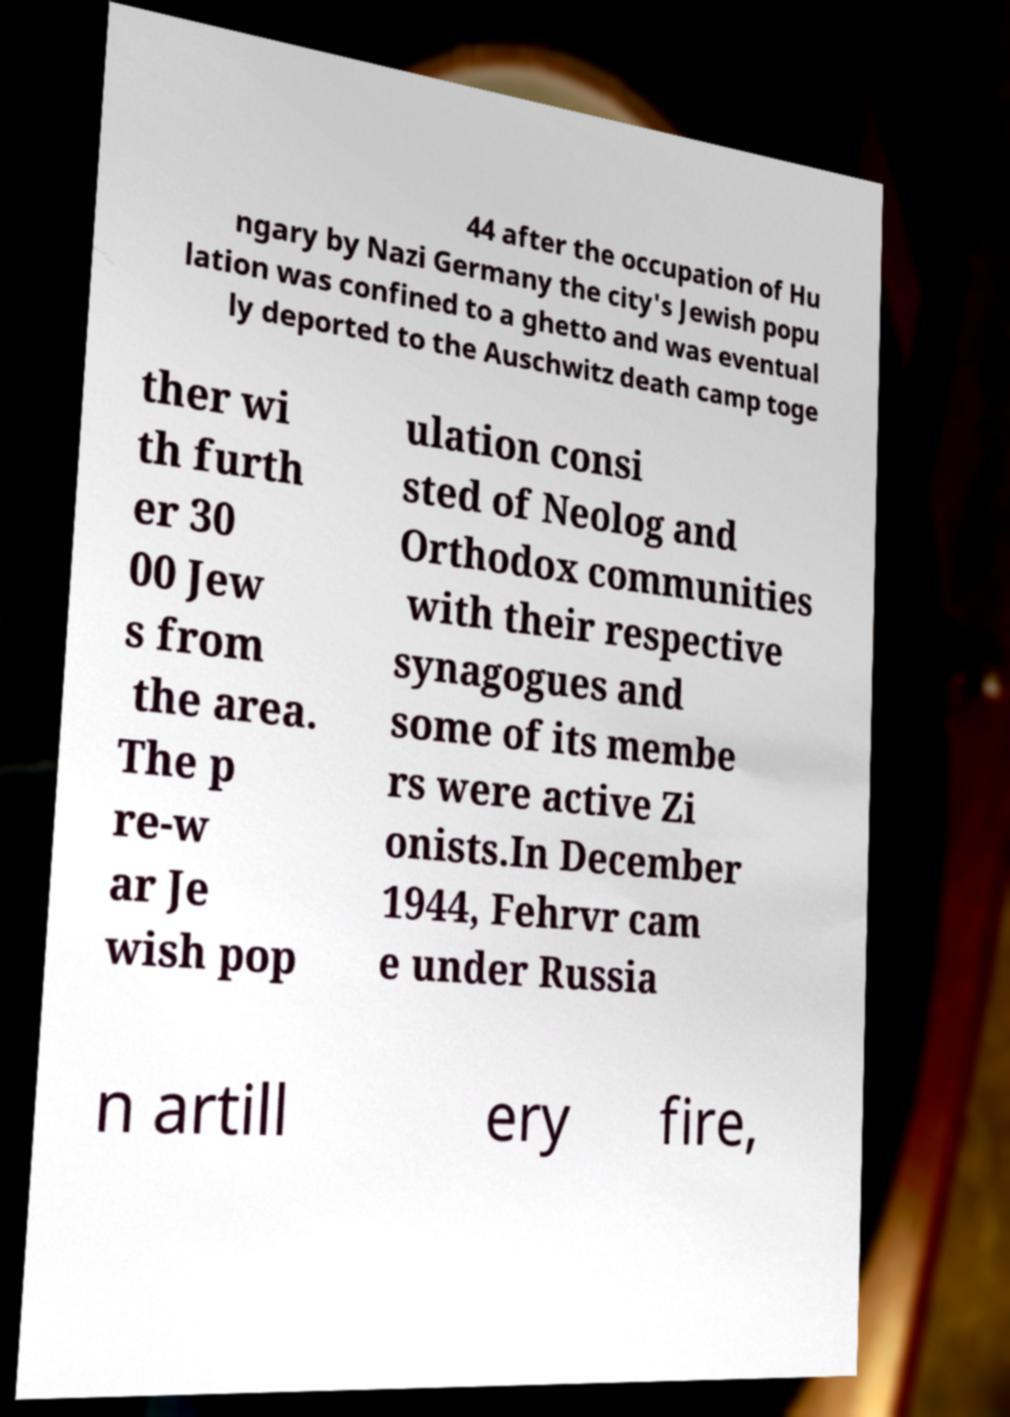For documentation purposes, I need the text within this image transcribed. Could you provide that? 44 after the occupation of Hu ngary by Nazi Germany the city's Jewish popu lation was confined to a ghetto and was eventual ly deported to the Auschwitz death camp toge ther wi th furth er 30 00 Jew s from the area. The p re-w ar Je wish pop ulation consi sted of Neolog and Orthodox communities with their respective synagogues and some of its membe rs were active Zi onists.In December 1944, Fehrvr cam e under Russia n artill ery fire, 